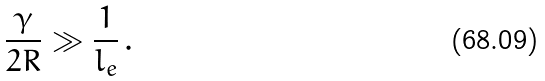<formula> <loc_0><loc_0><loc_500><loc_500>\frac { \gamma } { 2 R } \gg \frac { 1 } { l _ { e } } \, .</formula> 